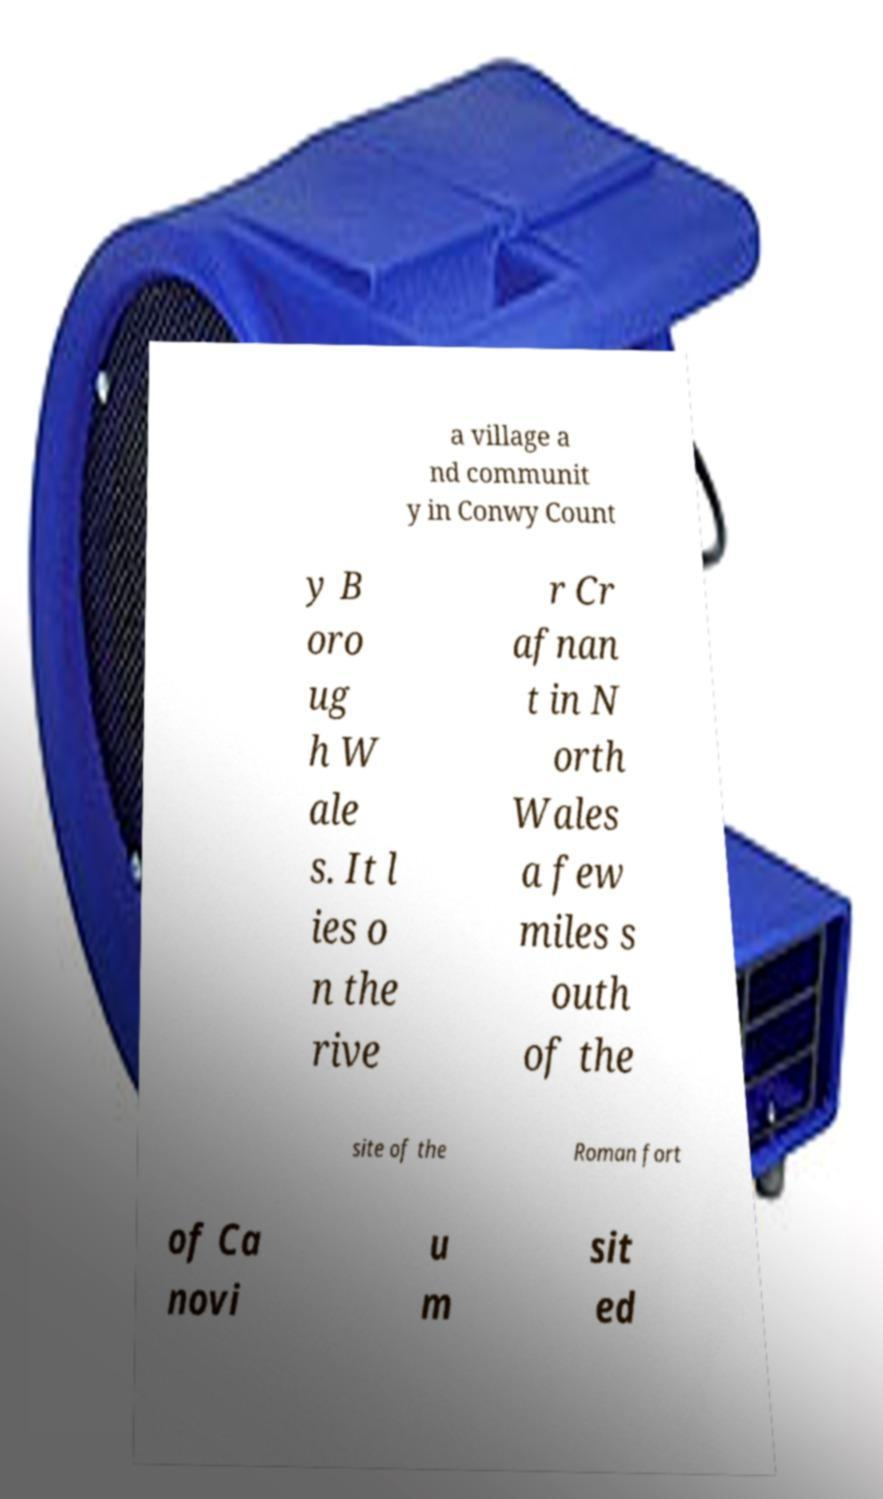For documentation purposes, I need the text within this image transcribed. Could you provide that? a village a nd communit y in Conwy Count y B oro ug h W ale s. It l ies o n the rive r Cr afnan t in N orth Wales a few miles s outh of the site of the Roman fort of Ca novi u m sit ed 